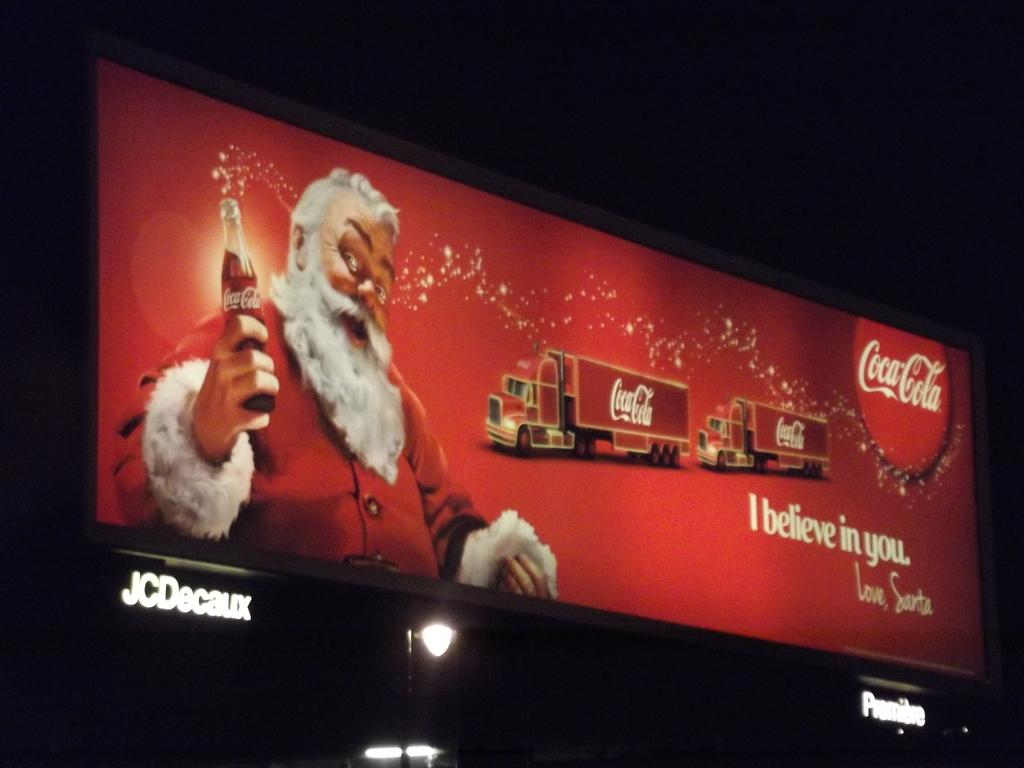<image>
Render a clear and concise summary of the photo. A CocaCola advertisement featuring santa holding a Coke and the phrase I believe in you. 